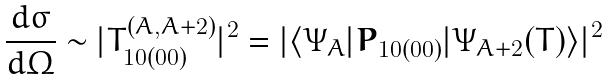Convert formula to latex. <formula><loc_0><loc_0><loc_500><loc_500>\frac { d \sigma } { d \Omega } \sim | T ^ { ( A , A + 2 ) } _ { 1 0 ( 0 0 ) } | ^ { 2 } = | \langle \Psi _ { A } | { \boldsymbol P } _ { 1 0 ( 0 0 ) } | \Psi _ { A + 2 } ( T ) \rangle | ^ { 2 }</formula> 